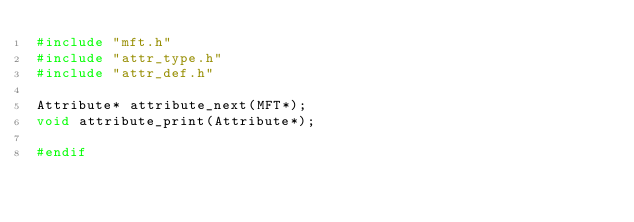Convert code to text. <code><loc_0><loc_0><loc_500><loc_500><_C_>#include "mft.h"
#include "attr_type.h"
#include "attr_def.h"

Attribute* attribute_next(MFT*);
void attribute_print(Attribute*);

#endif
</code> 